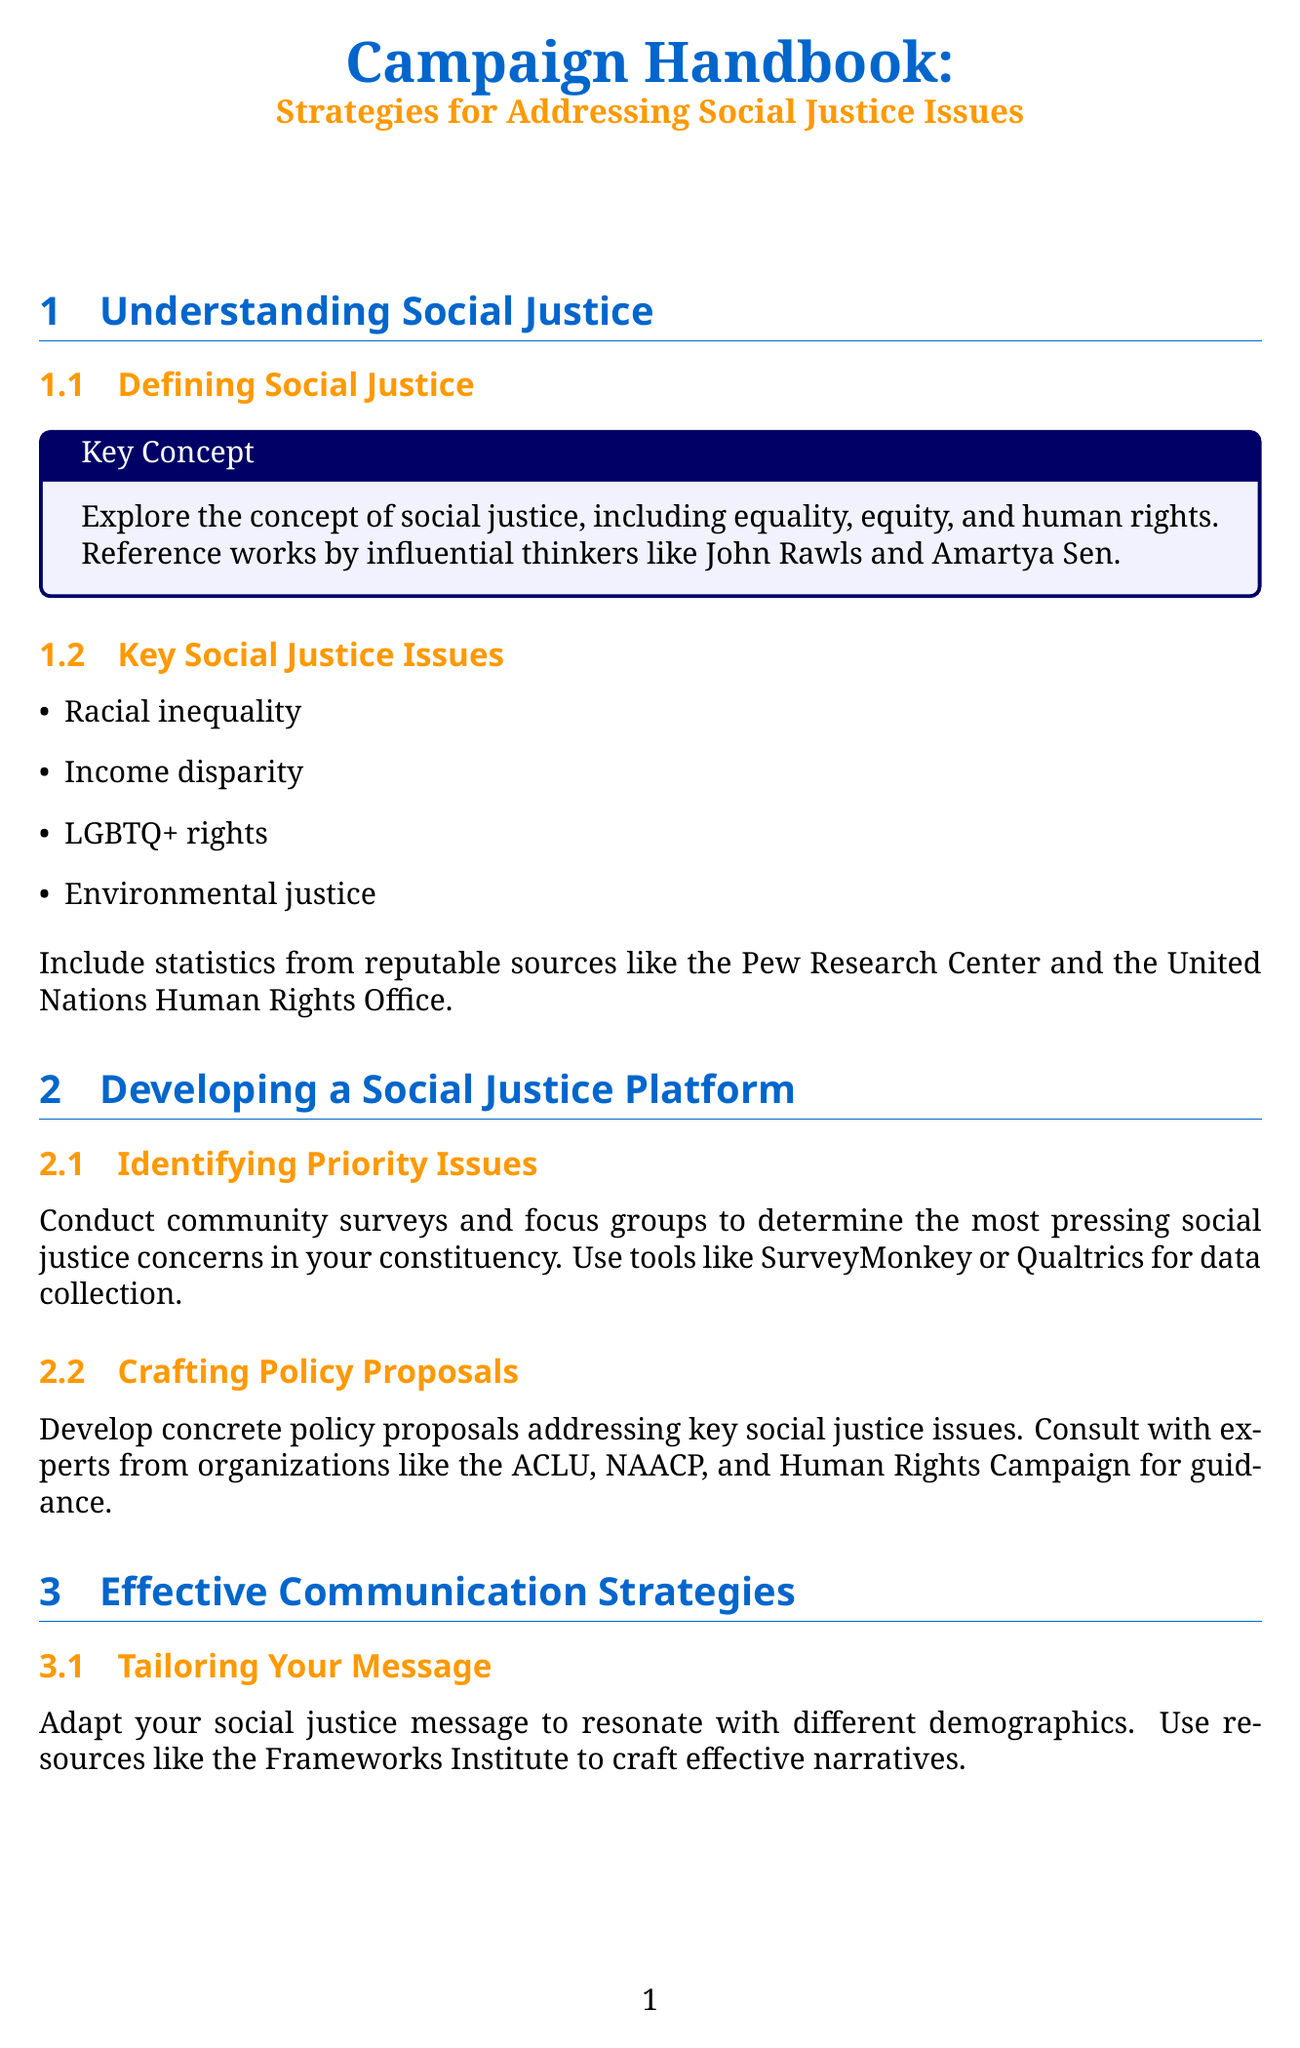What is the title of the document? The title of the document is explicitly stated at the beginning.
Answer: Campaign Handbook: Strategies for Addressing Social Justice Issues Who are two influential thinkers mentioned in the document? The document references John Rawls and Amartya Sen in the section about defining social justice.
Answer: John Rawls, Amartya Sen What tool can be used for community surveys? The document suggests using tools like SurveyMonkey or Qualtrics for collecting data.
Answer: SurveyMonkey What is one key social justice issue listed? The document highlights a number of pressing social justice issues, one of which is racial inequality.
Answer: Racial inequality What is a recommended method for engaging in dialogue? The document suggests referencing works by authors like Ibram X. Kendi and Robin DiAngelo for constructive dialogue.
Answer: Ibram X. Kendi, Robin DiAngelo What platform can be used for fundraising campaigns? The document mentions platforms like GoFundMe or ActBlue for organizing fundraising events.
Answer: GoFundMe How can campaign success be measured? The document discusses developing key performance indicators (KPIs) to measure success.
Answer: Key performance indicators (KPIs) What type of events does the document suggest for community engagement? The document recommends hosting town halls, panel discussions, and awareness campaigns.
Answer: Town halls, panel discussions, and awareness campaigns Who can be potential allies for building coalitions? The document mentions local activist groups, labor unions, and community organizations as potential allies.
Answer: Local activist groups, labor unions, and community organizations 